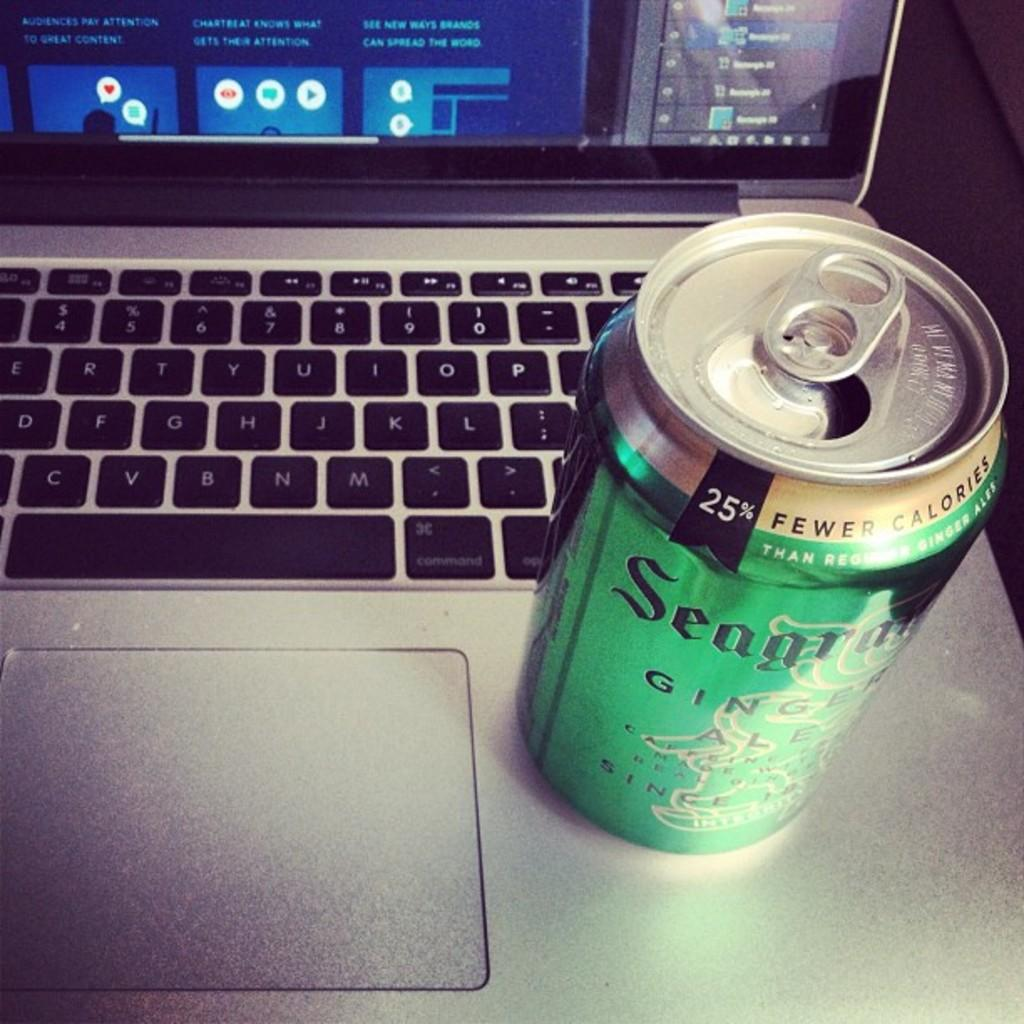<image>
Share a concise interpretation of the image provided. A laptop with a largely green can of ginger ale on it. 